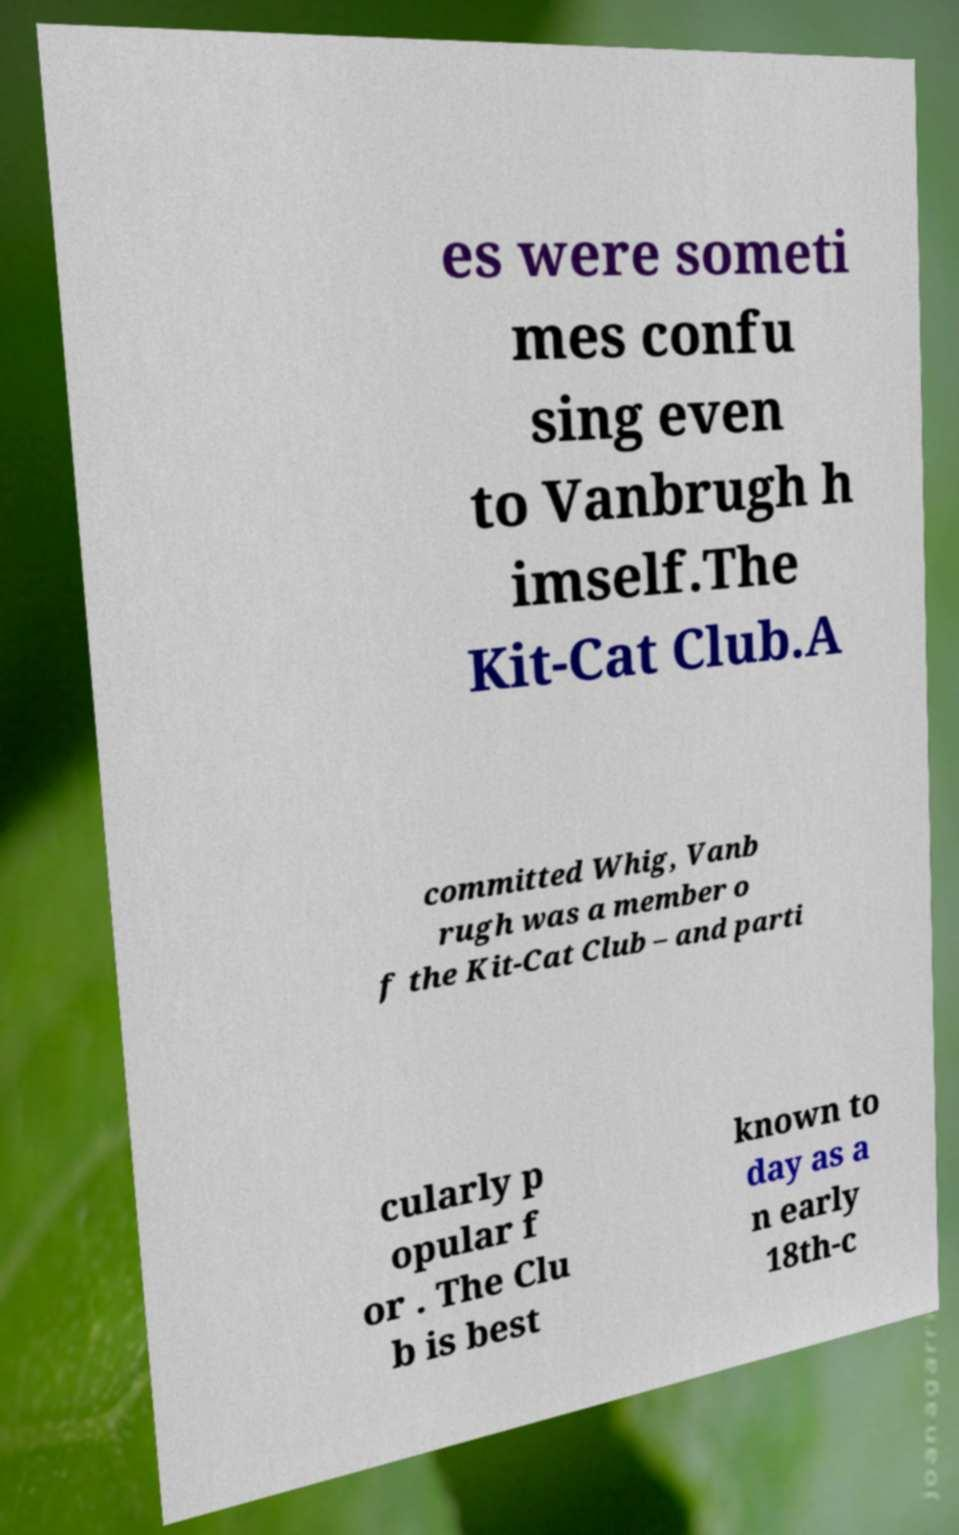I need the written content from this picture converted into text. Can you do that? es were someti mes confu sing even to Vanbrugh h imself.The Kit-Cat Club.A committed Whig, Vanb rugh was a member o f the Kit-Cat Club – and parti cularly p opular f or . The Clu b is best known to day as a n early 18th-c 